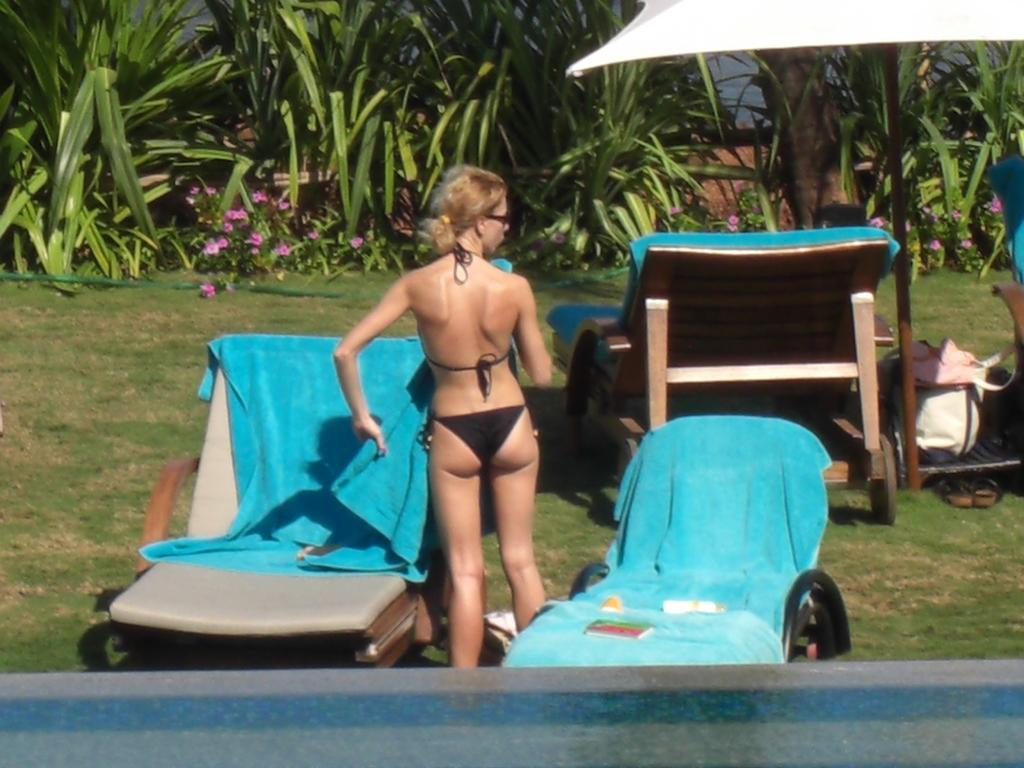Who is the main subject in the image? There is a woman in the image. What is the woman wearing? The woman is wearing a bikini. What is the woman holding in her left hand? The woman is holding a blue towel in her left hand. What can be seen in the background of the image? There are trees in the background of the image. What type of beef is being served on the plate in the image? There is no plate or beef present in the image; it features a woman wearing a bikini and holding a blue towel. How many hens are visible in the image? There are no hens present in the image. 